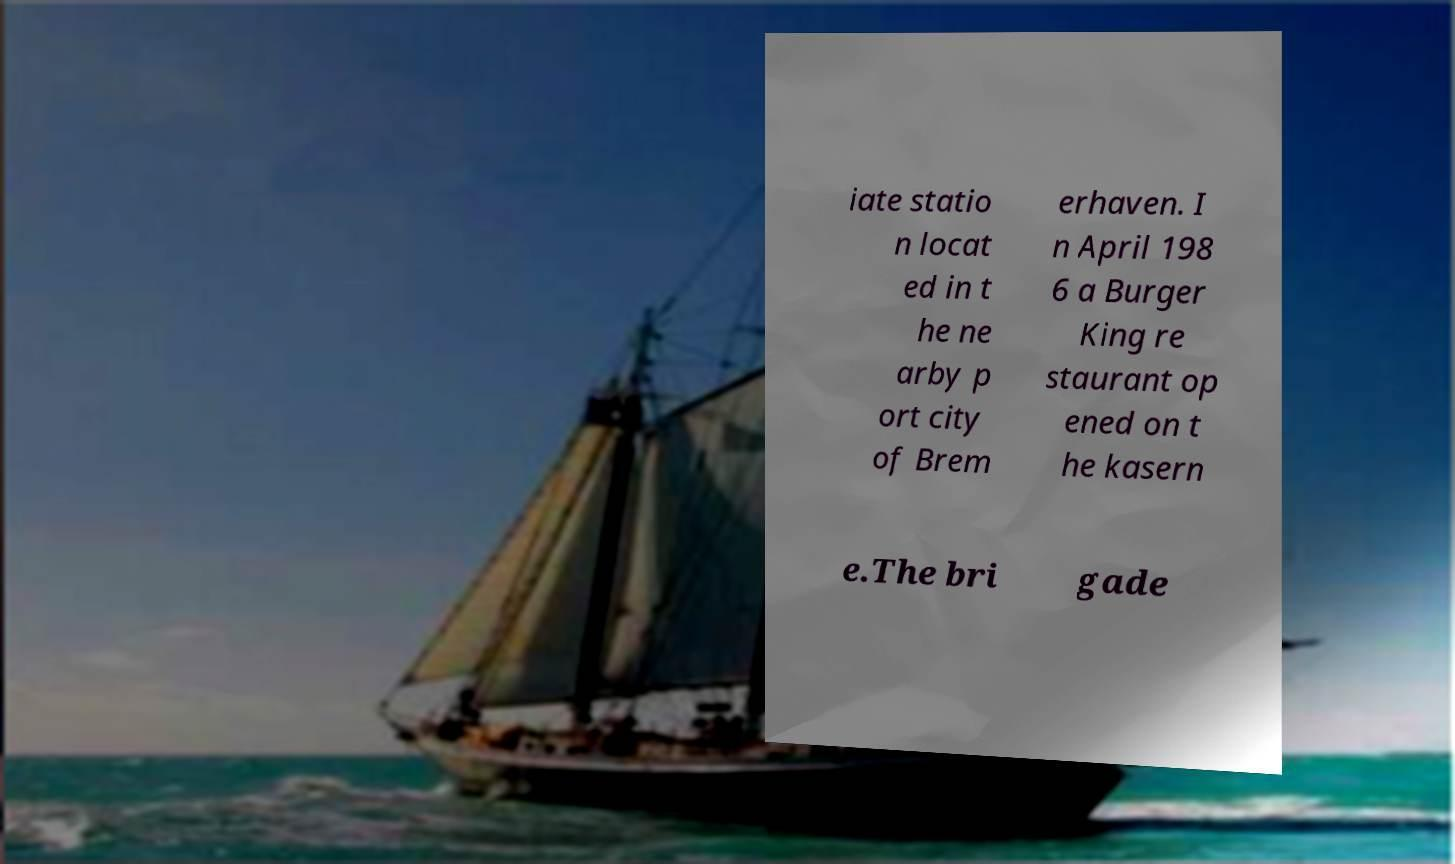Please identify and transcribe the text found in this image. iate statio n locat ed in t he ne arby p ort city of Brem erhaven. I n April 198 6 a Burger King re staurant op ened on t he kasern e.The bri gade 